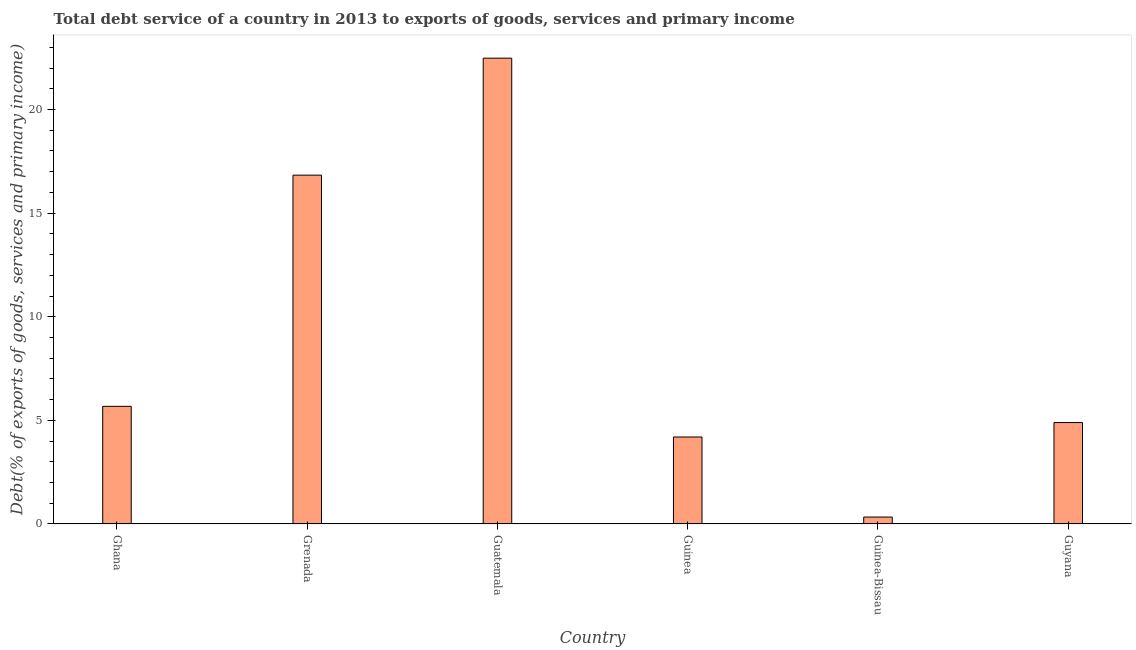What is the title of the graph?
Ensure brevity in your answer.  Total debt service of a country in 2013 to exports of goods, services and primary income. What is the label or title of the X-axis?
Offer a very short reply. Country. What is the label or title of the Y-axis?
Give a very brief answer. Debt(% of exports of goods, services and primary income). What is the total debt service in Guatemala?
Your answer should be compact. 22.48. Across all countries, what is the maximum total debt service?
Provide a short and direct response. 22.48. Across all countries, what is the minimum total debt service?
Ensure brevity in your answer.  0.33. In which country was the total debt service maximum?
Keep it short and to the point. Guatemala. In which country was the total debt service minimum?
Provide a short and direct response. Guinea-Bissau. What is the sum of the total debt service?
Offer a very short reply. 54.41. What is the difference between the total debt service in Grenada and Guinea-Bissau?
Offer a terse response. 16.5. What is the average total debt service per country?
Make the answer very short. 9.07. What is the median total debt service?
Offer a very short reply. 5.29. In how many countries, is the total debt service greater than 2 %?
Keep it short and to the point. 5. What is the ratio of the total debt service in Ghana to that in Guinea?
Offer a terse response. 1.35. Is the total debt service in Grenada less than that in Guyana?
Provide a succinct answer. No. Is the difference between the total debt service in Grenada and Guinea greater than the difference between any two countries?
Ensure brevity in your answer.  No. What is the difference between the highest and the second highest total debt service?
Your answer should be very brief. 5.64. What is the difference between the highest and the lowest total debt service?
Your answer should be compact. 22.14. How many bars are there?
Ensure brevity in your answer.  6. How many countries are there in the graph?
Make the answer very short. 6. What is the Debt(% of exports of goods, services and primary income) of Ghana?
Offer a very short reply. 5.68. What is the Debt(% of exports of goods, services and primary income) in Grenada?
Provide a short and direct response. 16.83. What is the Debt(% of exports of goods, services and primary income) of Guatemala?
Your answer should be very brief. 22.48. What is the Debt(% of exports of goods, services and primary income) in Guinea?
Ensure brevity in your answer.  4.2. What is the Debt(% of exports of goods, services and primary income) in Guinea-Bissau?
Your answer should be compact. 0.33. What is the Debt(% of exports of goods, services and primary income) in Guyana?
Provide a succinct answer. 4.89. What is the difference between the Debt(% of exports of goods, services and primary income) in Ghana and Grenada?
Your answer should be very brief. -11.16. What is the difference between the Debt(% of exports of goods, services and primary income) in Ghana and Guatemala?
Give a very brief answer. -16.8. What is the difference between the Debt(% of exports of goods, services and primary income) in Ghana and Guinea?
Provide a short and direct response. 1.48. What is the difference between the Debt(% of exports of goods, services and primary income) in Ghana and Guinea-Bissau?
Provide a short and direct response. 5.34. What is the difference between the Debt(% of exports of goods, services and primary income) in Ghana and Guyana?
Ensure brevity in your answer.  0.78. What is the difference between the Debt(% of exports of goods, services and primary income) in Grenada and Guatemala?
Make the answer very short. -5.64. What is the difference between the Debt(% of exports of goods, services and primary income) in Grenada and Guinea?
Keep it short and to the point. 12.63. What is the difference between the Debt(% of exports of goods, services and primary income) in Grenada and Guinea-Bissau?
Provide a succinct answer. 16.5. What is the difference between the Debt(% of exports of goods, services and primary income) in Grenada and Guyana?
Offer a terse response. 11.94. What is the difference between the Debt(% of exports of goods, services and primary income) in Guatemala and Guinea?
Your response must be concise. 18.28. What is the difference between the Debt(% of exports of goods, services and primary income) in Guatemala and Guinea-Bissau?
Make the answer very short. 22.14. What is the difference between the Debt(% of exports of goods, services and primary income) in Guatemala and Guyana?
Give a very brief answer. 17.58. What is the difference between the Debt(% of exports of goods, services and primary income) in Guinea and Guinea-Bissau?
Offer a very short reply. 3.86. What is the difference between the Debt(% of exports of goods, services and primary income) in Guinea and Guyana?
Provide a succinct answer. -0.7. What is the difference between the Debt(% of exports of goods, services and primary income) in Guinea-Bissau and Guyana?
Provide a succinct answer. -4.56. What is the ratio of the Debt(% of exports of goods, services and primary income) in Ghana to that in Grenada?
Give a very brief answer. 0.34. What is the ratio of the Debt(% of exports of goods, services and primary income) in Ghana to that in Guatemala?
Your answer should be very brief. 0.25. What is the ratio of the Debt(% of exports of goods, services and primary income) in Ghana to that in Guinea?
Your response must be concise. 1.35. What is the ratio of the Debt(% of exports of goods, services and primary income) in Ghana to that in Guinea-Bissau?
Provide a succinct answer. 16.99. What is the ratio of the Debt(% of exports of goods, services and primary income) in Ghana to that in Guyana?
Provide a succinct answer. 1.16. What is the ratio of the Debt(% of exports of goods, services and primary income) in Grenada to that in Guatemala?
Offer a very short reply. 0.75. What is the ratio of the Debt(% of exports of goods, services and primary income) in Grenada to that in Guinea?
Offer a very short reply. 4.01. What is the ratio of the Debt(% of exports of goods, services and primary income) in Grenada to that in Guinea-Bissau?
Offer a terse response. 50.37. What is the ratio of the Debt(% of exports of goods, services and primary income) in Grenada to that in Guyana?
Your answer should be very brief. 3.44. What is the ratio of the Debt(% of exports of goods, services and primary income) in Guatemala to that in Guinea?
Your response must be concise. 5.36. What is the ratio of the Debt(% of exports of goods, services and primary income) in Guatemala to that in Guinea-Bissau?
Offer a terse response. 67.26. What is the ratio of the Debt(% of exports of goods, services and primary income) in Guatemala to that in Guyana?
Give a very brief answer. 4.59. What is the ratio of the Debt(% of exports of goods, services and primary income) in Guinea to that in Guinea-Bissau?
Offer a terse response. 12.56. What is the ratio of the Debt(% of exports of goods, services and primary income) in Guinea to that in Guyana?
Your answer should be very brief. 0.86. What is the ratio of the Debt(% of exports of goods, services and primary income) in Guinea-Bissau to that in Guyana?
Your answer should be compact. 0.07. 